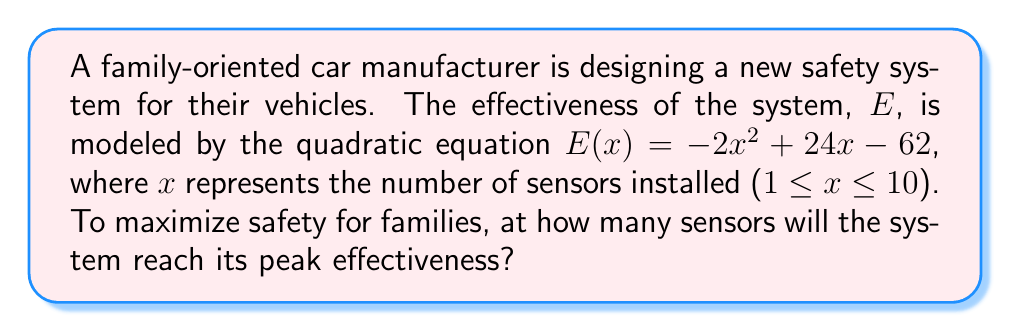Teach me how to tackle this problem. To find the number of sensors that maximize the effectiveness of the safety system, we need to find the vertex of the parabola represented by the quadratic equation. The vertex represents the maximum point of the parabola since the coefficient of $x^2$ is negative (opening downward).

1) For a quadratic equation in the form $ax^2 + bx + c$, the x-coordinate of the vertex is given by $x = -\frac{b}{2a}$.

2) In our equation $E(x) = -2x^2 + 24x - 62$, we have:
   $a = -2$
   $b = 24$
   $c = -62$

3) Applying the formula:
   $x = -\frac{b}{2a} = -\frac{24}{2(-2)} = -\frac{24}{-4} = 6$

4) To verify this is a maximum (not minimum), we confirm that $a < 0$ (which it is: $a = -2$).

5) We can also calculate the maximum effectiveness by plugging x = 6 into the original equation:
   $E(6) = -2(6)^2 + 24(6) - 62$
   $= -2(36) + 144 - 62$
   $= -72 + 144 - 62$
   $= 10$

Therefore, the effectiveness of the safety system reaches its peak when 6 sensors are installed.
Answer: 6 sensors 